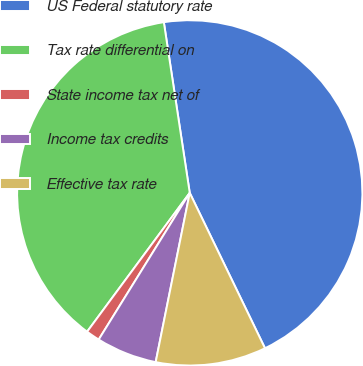Convert chart. <chart><loc_0><loc_0><loc_500><loc_500><pie_chart><fcel>US Federal statutory rate<fcel>Tax rate differential on<fcel>State income tax net of<fcel>Income tax credits<fcel>Effective tax rate<nl><fcel>45.22%<fcel>37.47%<fcel>1.29%<fcel>5.68%<fcel>10.34%<nl></chart> 